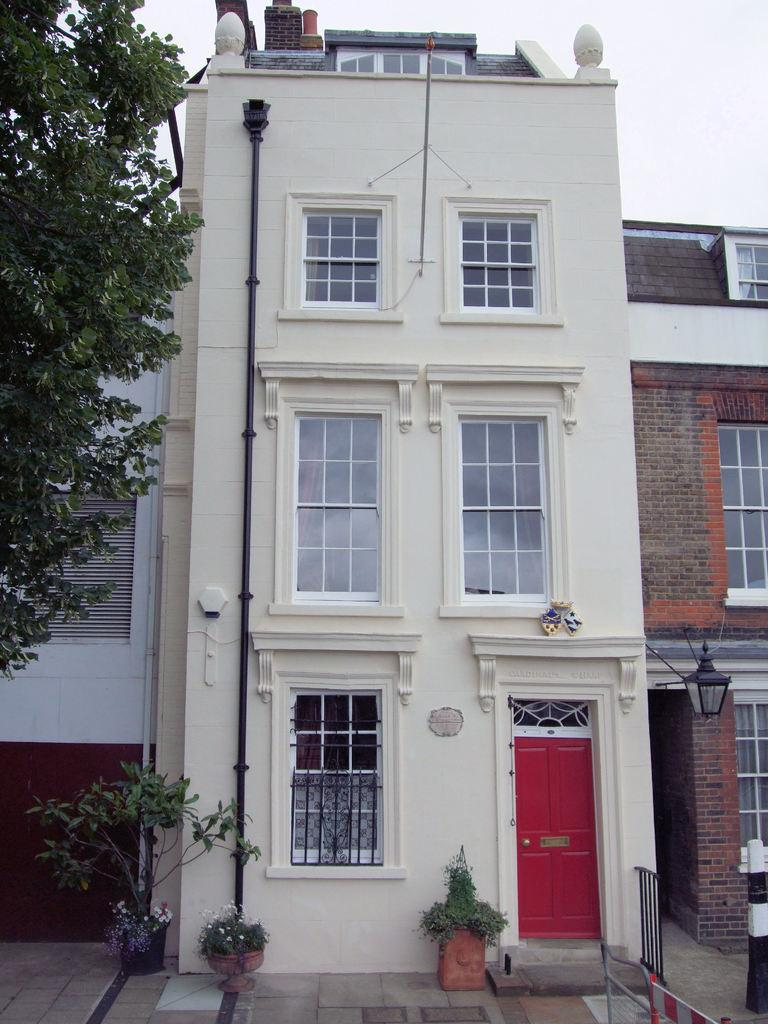What type of structures can be seen in the image? There are buildings in the image. What other elements are present in the image besides the buildings? There are plants and a tree in the image. Where is the tree located in the image? The tree is in the front of the image. What can be seen in the background of the image? The sky is visible in the background of the image. What architectural feature is present on the right side of the image? There is railing on the right side of the image. How many jellyfish are swimming in the image? There are no jellyfish present in the image; it features buildings, plants, a tree, and railing. What type of fruit is being harvested by the minister in the image? There is no minister or fruit harvesting present in the image. 